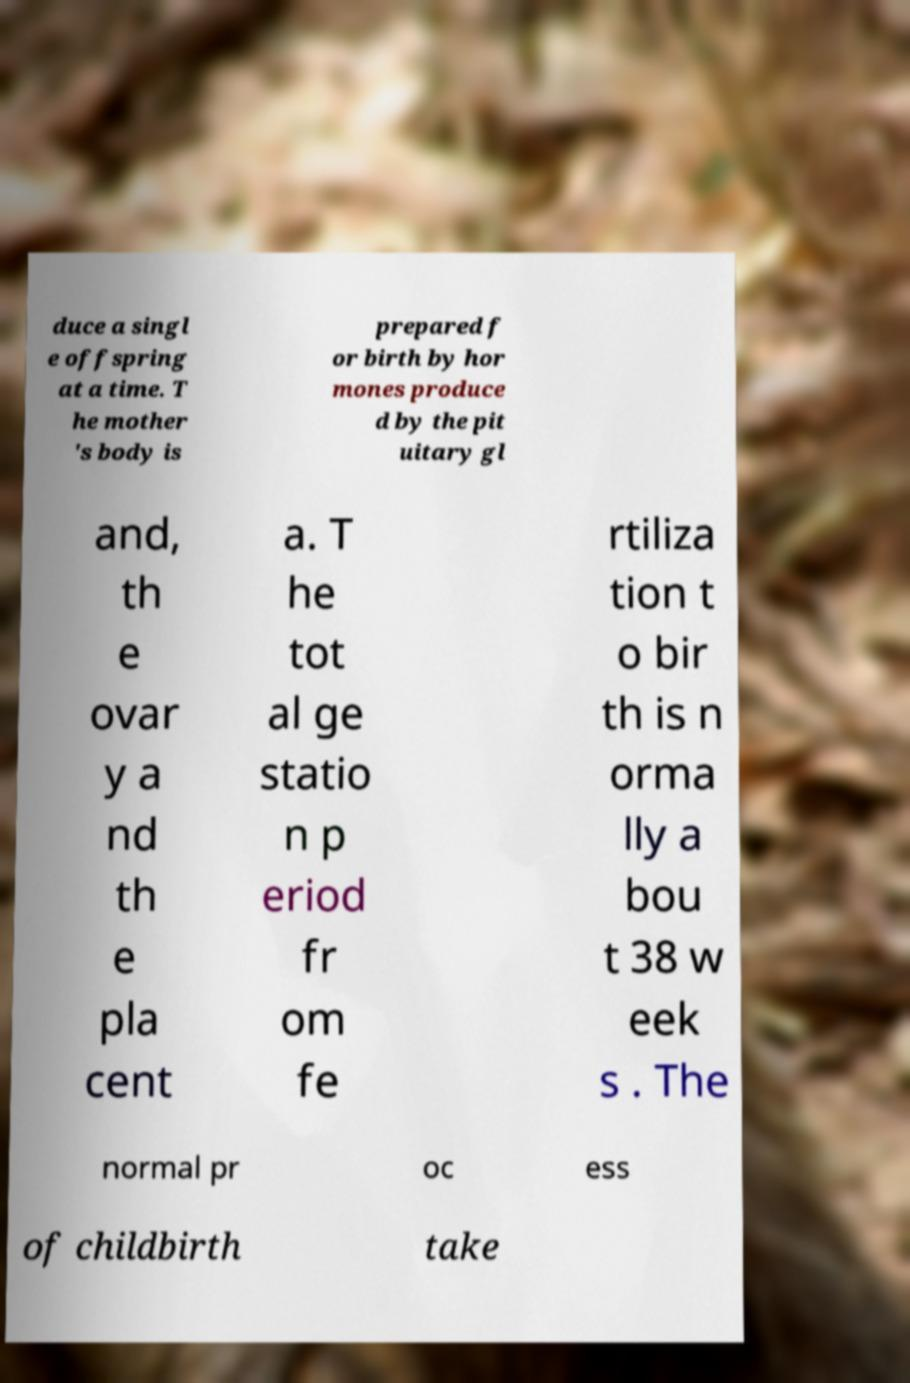There's text embedded in this image that I need extracted. Can you transcribe it verbatim? duce a singl e offspring at a time. T he mother 's body is prepared f or birth by hor mones produce d by the pit uitary gl and, th e ovar y a nd th e pla cent a. T he tot al ge statio n p eriod fr om fe rtiliza tion t o bir th is n orma lly a bou t 38 w eek s . The normal pr oc ess of childbirth take 